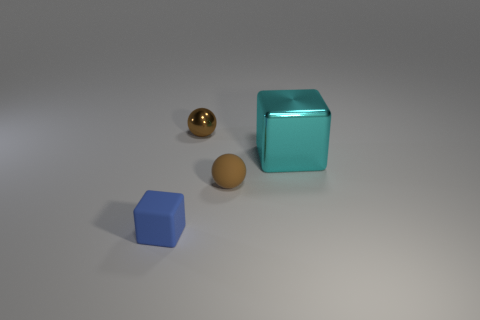Can you describe the lighting and shadows in the scene? The image is lit from above, casting soft shadows to the lower right side of each object, indicating a single diffuse light source above the scene. 